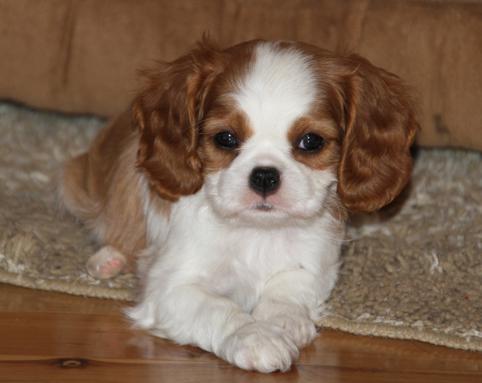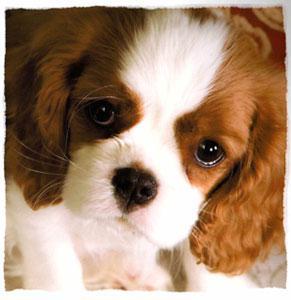The first image is the image on the left, the second image is the image on the right. Considering the images on both sides, is "Ine one of the images only the dog's head is visible" valid? Answer yes or no. Yes. The first image is the image on the left, the second image is the image on the right. Analyze the images presented: Is the assertion "An image shows a brown and white puppy on a shiny wood floor." valid? Answer yes or no. Yes. 